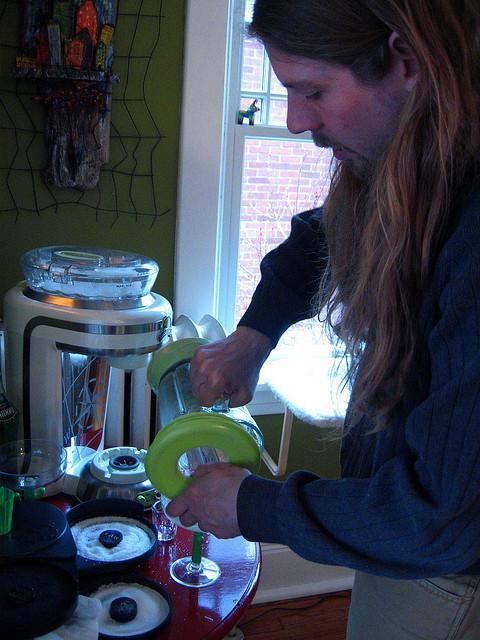How many people are there?
Give a very brief answer. 1. 